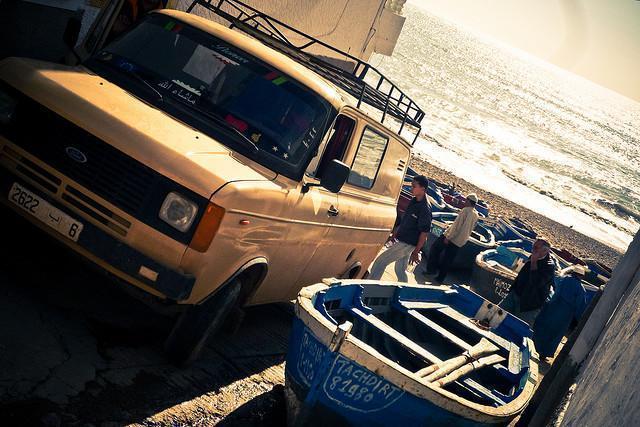What are the first two numbers on the truck?
Answer the question by selecting the correct answer among the 4 following choices.
Options: 45, 96, 88, 26. 26. 